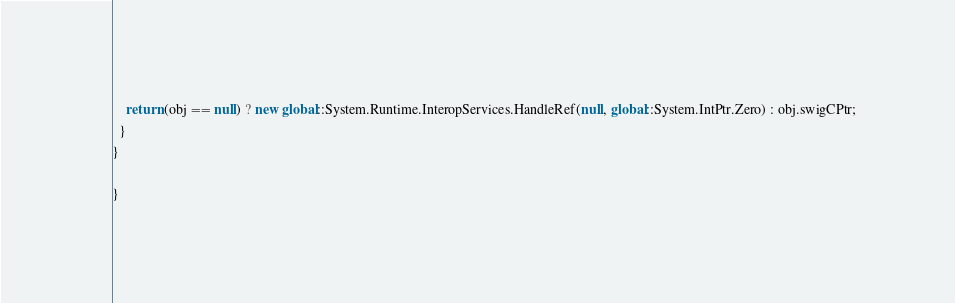<code> <loc_0><loc_0><loc_500><loc_500><_C#_>    return (obj == null) ? new global::System.Runtime.InteropServices.HandleRef(null, global::System.IntPtr.Zero) : obj.swigCPtr;
  }
}

}
</code> 